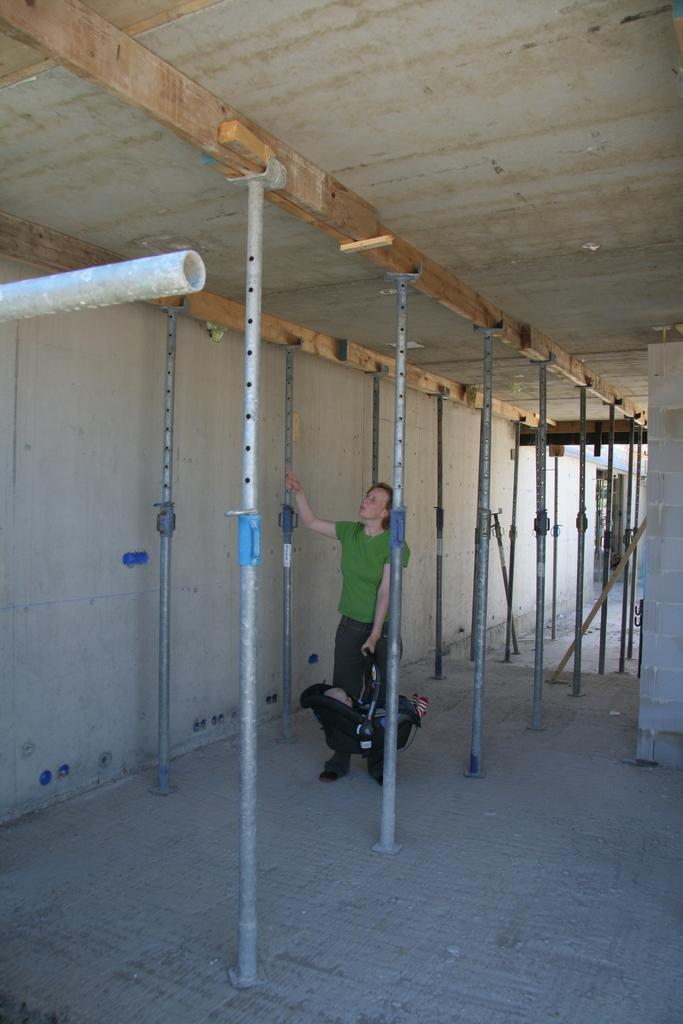What is the person in the image wearing? The person is wearing a green t-shirt. What can be seen in the background of the image? There is a wall in the image. What is above the person in the image? There is a ceiling in the image. What is on the ground in the image? There are other objects on the ground in the image. How many bikes are leaning against the wall in the image? There are no bikes present in the image. What type of beam is holding up the ceiling in the image? There is no beam visible in the image; only the ceiling is mentioned. 